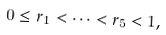Convert formula to latex. <formula><loc_0><loc_0><loc_500><loc_500>0 \leq r _ { 1 } < \cdots < r _ { 5 } < 1 ,</formula> 